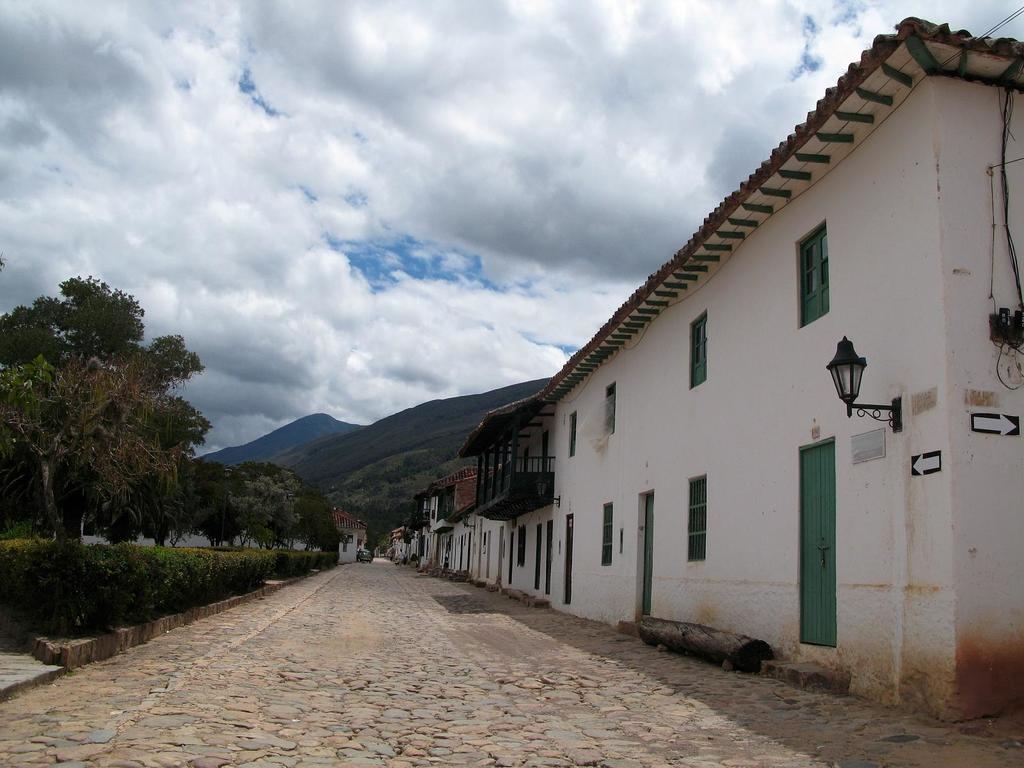What structures are located in the middle of the image? There are buildings in the middle of the image. What type of vegetation can be seen in the image? There are trees and plants in the image. What natural features are visible behind the buildings? There are hills visible behind the buildings. What is present at the top of the image? There are clouds at the top of the image. What part of the natural environment is visible in the image? The sky is visible in the image. Can you pull the sheet off the trees in the image? There is no sheet present in the image, and therefore it cannot be pulled off the trees. 